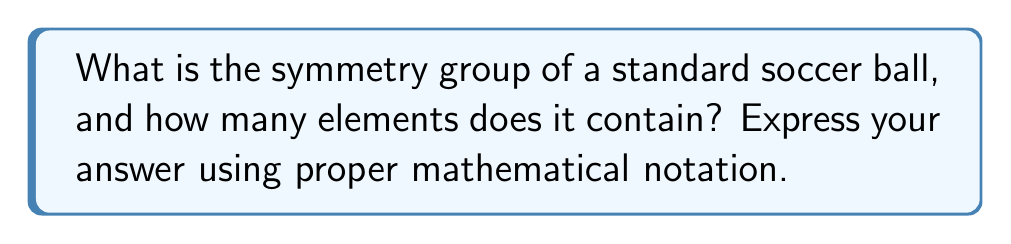Teach me how to tackle this problem. Let's approach this step-by-step:

1) A standard soccer ball is made up of 12 regular pentagons and 20 regular hexagons. This shape is known as a truncated icosahedron.

2) The symmetry group of a soccer ball is the same as the symmetry group of a truncated icosahedron.

3) The truncated icosahedron belongs to the icosahedral symmetry group, which is isomorphic to the alternating group $A_5$.

4) However, the full symmetry group of the truncated icosahedron (and thus the soccer ball) is larger than just $A_5$. It includes both rotations and reflections.

5) The full symmetry group is actually the direct product of $A_5$ with the cyclic group of order 2, $C_2$. In mathematical notation, this is written as:

   $A_5 \times C_2$

6) To calculate the number of elements:
   - $A_5$ has 60 elements (half of the 120 elements in the symmetric group $S_5$)
   - $C_2$ has 2 elements

7) The number of elements in a direct product is the product of the number of elements in each group. So:

   $|A_5 \times C_2| = |A_5| \cdot |C_2| = 60 \cdot 2 = 120$

Therefore, the symmetry group has 120 elements.
Answer: $A_5 \times C_2$, 120 elements 